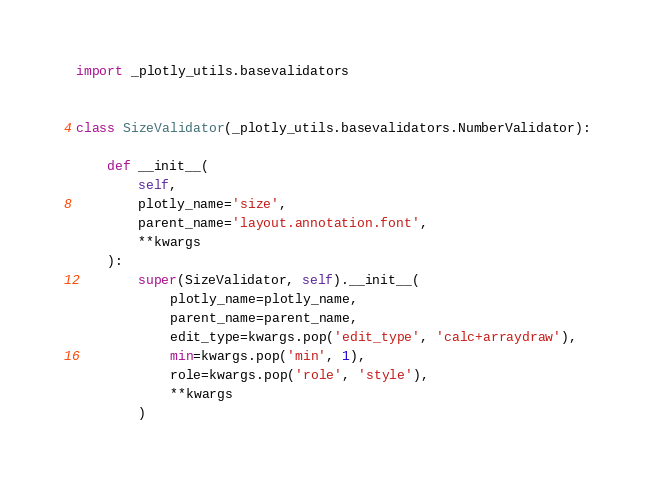<code> <loc_0><loc_0><loc_500><loc_500><_Python_>import _plotly_utils.basevalidators


class SizeValidator(_plotly_utils.basevalidators.NumberValidator):

    def __init__(
        self,
        plotly_name='size',
        parent_name='layout.annotation.font',
        **kwargs
    ):
        super(SizeValidator, self).__init__(
            plotly_name=plotly_name,
            parent_name=parent_name,
            edit_type=kwargs.pop('edit_type', 'calc+arraydraw'),
            min=kwargs.pop('min', 1),
            role=kwargs.pop('role', 'style'),
            **kwargs
        )
</code> 